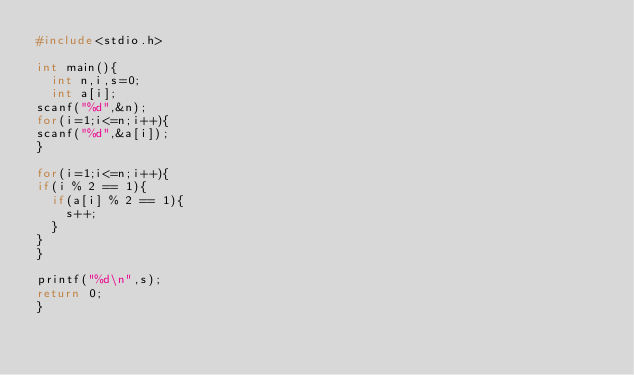<code> <loc_0><loc_0><loc_500><loc_500><_C_>#include<stdio.h>

int main(){
  int n,i,s=0;
  int a[i];
scanf("%d",&n);
for(i=1;i<=n;i++){
scanf("%d",&a[i]);
}

for(i=1;i<=n;i++){
if(i % 2 == 1){
  if(a[i] % 2 == 1){
    s++;
  }
}
}

printf("%d\n",s);
return 0;
}</code> 